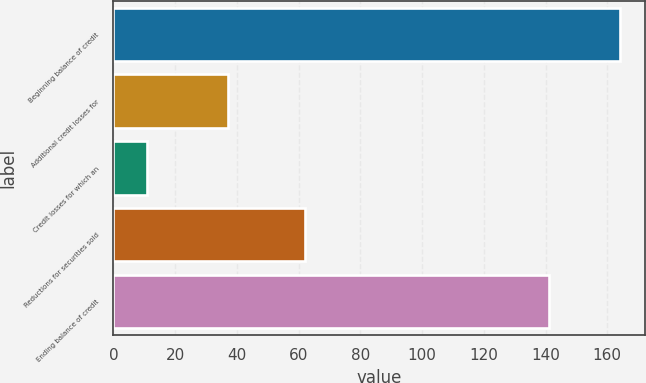Convert chart. <chart><loc_0><loc_0><loc_500><loc_500><bar_chart><fcel>Beginning balance of credit<fcel>Additional credit losses for<fcel>Credit losses for which an<fcel>Reductions for securities sold<fcel>Ending balance of credit<nl><fcel>164<fcel>37<fcel>11<fcel>62<fcel>141<nl></chart> 